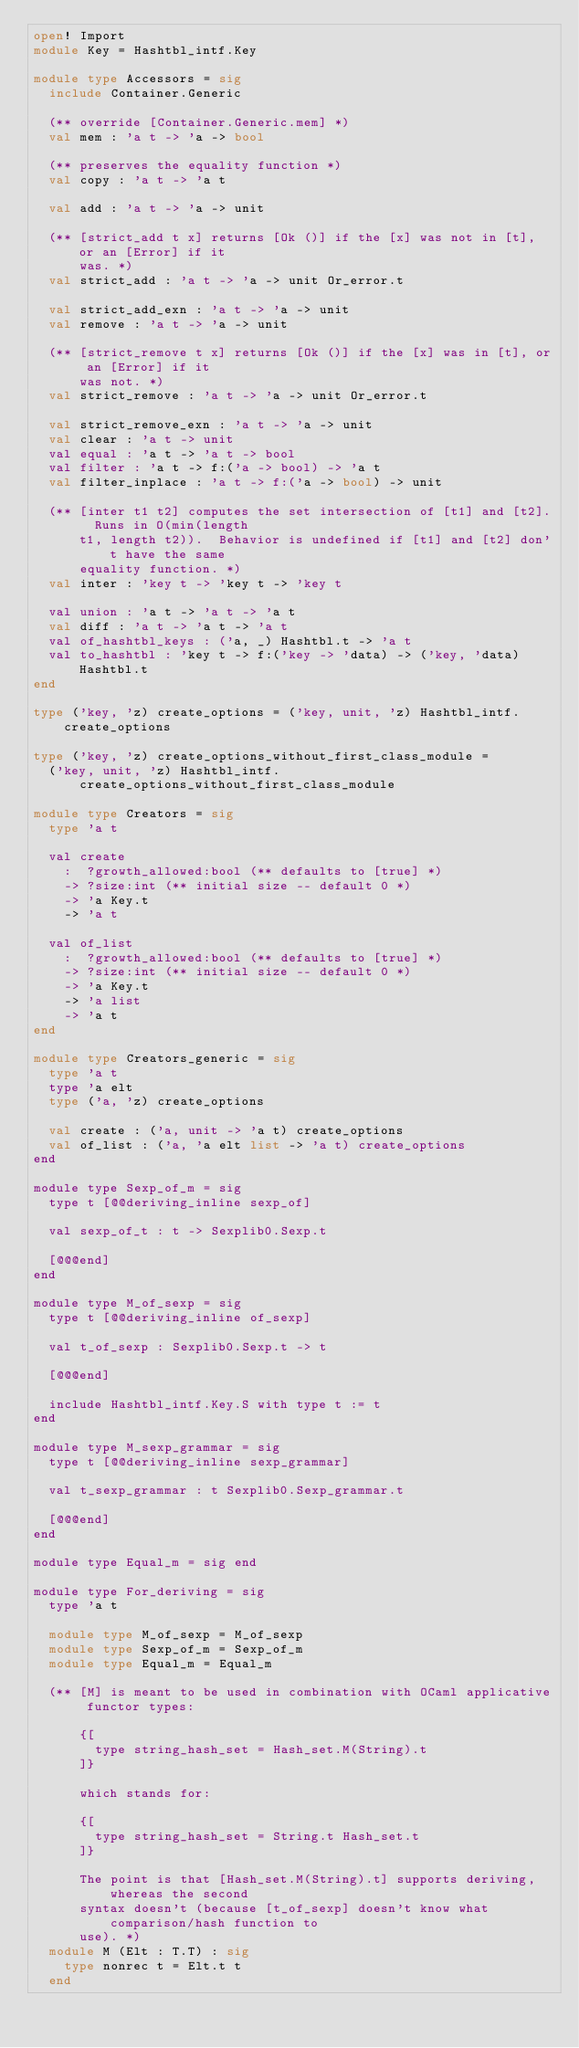<code> <loc_0><loc_0><loc_500><loc_500><_OCaml_>open! Import
module Key = Hashtbl_intf.Key

module type Accessors = sig
  include Container.Generic

  (** override [Container.Generic.mem] *)
  val mem : 'a t -> 'a -> bool

  (** preserves the equality function *)
  val copy : 'a t -> 'a t

  val add : 'a t -> 'a -> unit

  (** [strict_add t x] returns [Ok ()] if the [x] was not in [t], or an [Error] if it
      was. *)
  val strict_add : 'a t -> 'a -> unit Or_error.t

  val strict_add_exn : 'a t -> 'a -> unit
  val remove : 'a t -> 'a -> unit

  (** [strict_remove t x] returns [Ok ()] if the [x] was in [t], or an [Error] if it
      was not. *)
  val strict_remove : 'a t -> 'a -> unit Or_error.t

  val strict_remove_exn : 'a t -> 'a -> unit
  val clear : 'a t -> unit
  val equal : 'a t -> 'a t -> bool
  val filter : 'a t -> f:('a -> bool) -> 'a t
  val filter_inplace : 'a t -> f:('a -> bool) -> unit

  (** [inter t1 t2] computes the set intersection of [t1] and [t2].  Runs in O(min(length
      t1, length t2)).  Behavior is undefined if [t1] and [t2] don't have the same
      equality function. *)
  val inter : 'key t -> 'key t -> 'key t

  val union : 'a t -> 'a t -> 'a t
  val diff : 'a t -> 'a t -> 'a t
  val of_hashtbl_keys : ('a, _) Hashtbl.t -> 'a t
  val to_hashtbl : 'key t -> f:('key -> 'data) -> ('key, 'data) Hashtbl.t
end

type ('key, 'z) create_options = ('key, unit, 'z) Hashtbl_intf.create_options

type ('key, 'z) create_options_without_first_class_module =
  ('key, unit, 'z) Hashtbl_intf.create_options_without_first_class_module

module type Creators = sig
  type 'a t

  val create
    :  ?growth_allowed:bool (** defaults to [true] *)
    -> ?size:int (** initial size -- default 0 *)
    -> 'a Key.t
    -> 'a t

  val of_list
    :  ?growth_allowed:bool (** defaults to [true] *)
    -> ?size:int (** initial size -- default 0 *)
    -> 'a Key.t
    -> 'a list
    -> 'a t
end

module type Creators_generic = sig
  type 'a t
  type 'a elt
  type ('a, 'z) create_options

  val create : ('a, unit -> 'a t) create_options
  val of_list : ('a, 'a elt list -> 'a t) create_options
end

module type Sexp_of_m = sig
  type t [@@deriving_inline sexp_of]

  val sexp_of_t : t -> Sexplib0.Sexp.t

  [@@@end]
end

module type M_of_sexp = sig
  type t [@@deriving_inline of_sexp]

  val t_of_sexp : Sexplib0.Sexp.t -> t

  [@@@end]

  include Hashtbl_intf.Key.S with type t := t
end

module type M_sexp_grammar = sig
  type t [@@deriving_inline sexp_grammar]

  val t_sexp_grammar : t Sexplib0.Sexp_grammar.t

  [@@@end]
end

module type Equal_m = sig end

module type For_deriving = sig
  type 'a t

  module type M_of_sexp = M_of_sexp
  module type Sexp_of_m = Sexp_of_m
  module type Equal_m = Equal_m

  (** [M] is meant to be used in combination with OCaml applicative functor types:

      {[
        type string_hash_set = Hash_set.M(String).t
      ]}

      which stands for:

      {[
        type string_hash_set = String.t Hash_set.t
      ]}

      The point is that [Hash_set.M(String).t] supports deriving, whereas the second
      syntax doesn't (because [t_of_sexp] doesn't know what comparison/hash function to
      use). *)
  module M (Elt : T.T) : sig
    type nonrec t = Elt.t t
  end
</code> 